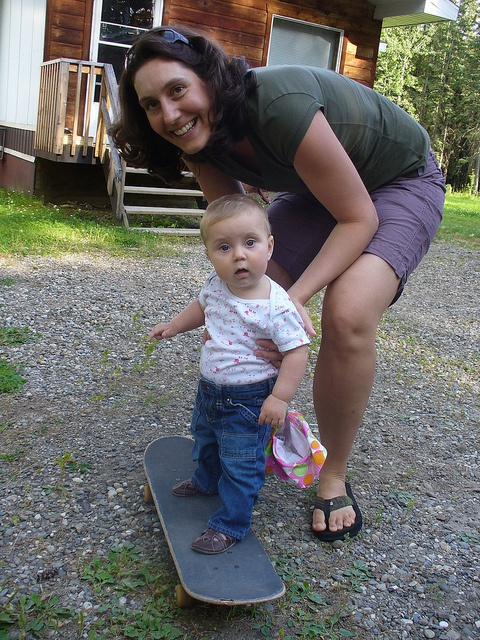Describe the objects in this image and their specific colors. I can see people in gray, black, and maroon tones, people in gray, navy, darkgray, and black tones, and skateboard in gray, black, and blue tones in this image. 